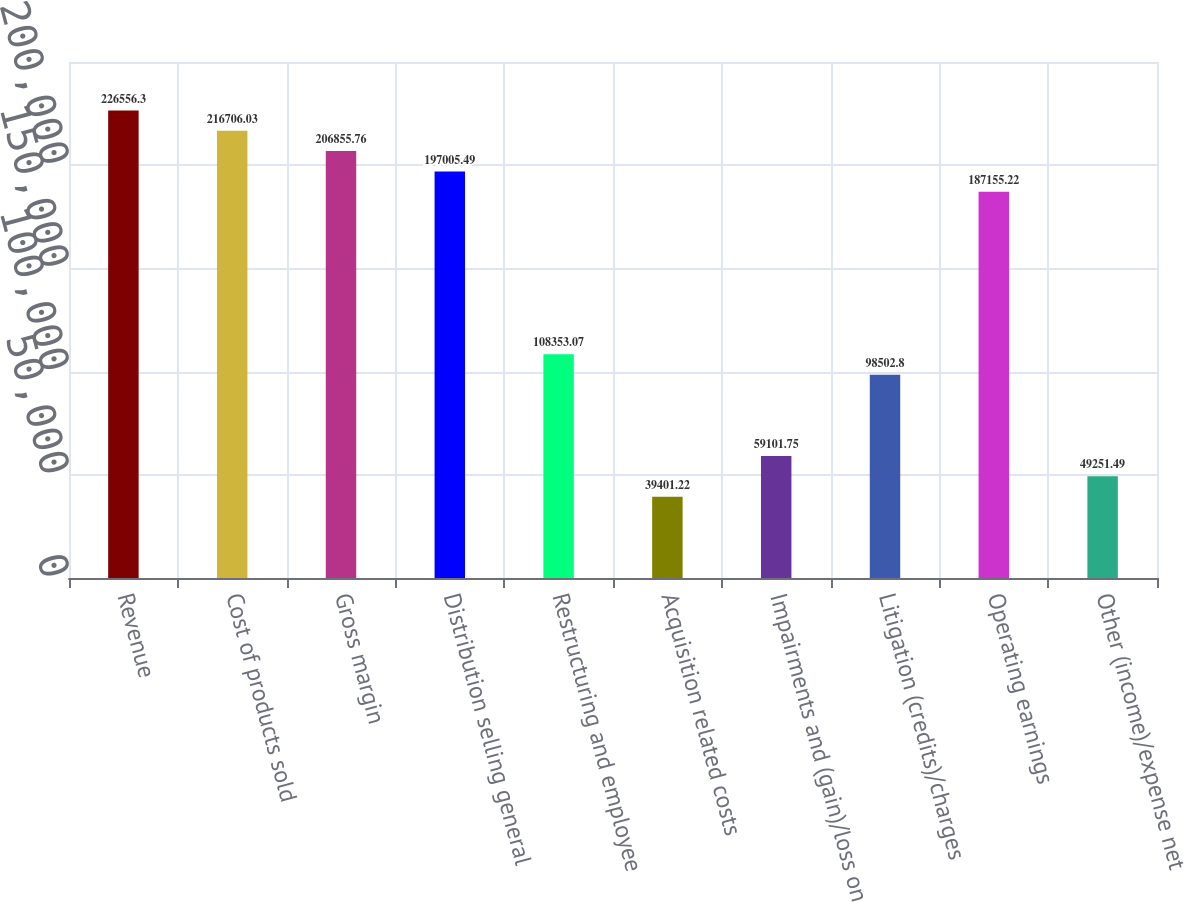Convert chart. <chart><loc_0><loc_0><loc_500><loc_500><bar_chart><fcel>Revenue<fcel>Cost of products sold<fcel>Gross margin<fcel>Distribution selling general<fcel>Restructuring and employee<fcel>Acquisition related costs<fcel>Impairments and (gain)/loss on<fcel>Litigation (credits)/charges<fcel>Operating earnings<fcel>Other (income)/expense net<nl><fcel>226556<fcel>216706<fcel>206856<fcel>197005<fcel>108353<fcel>39401.2<fcel>59101.8<fcel>98502.8<fcel>187155<fcel>49251.5<nl></chart> 